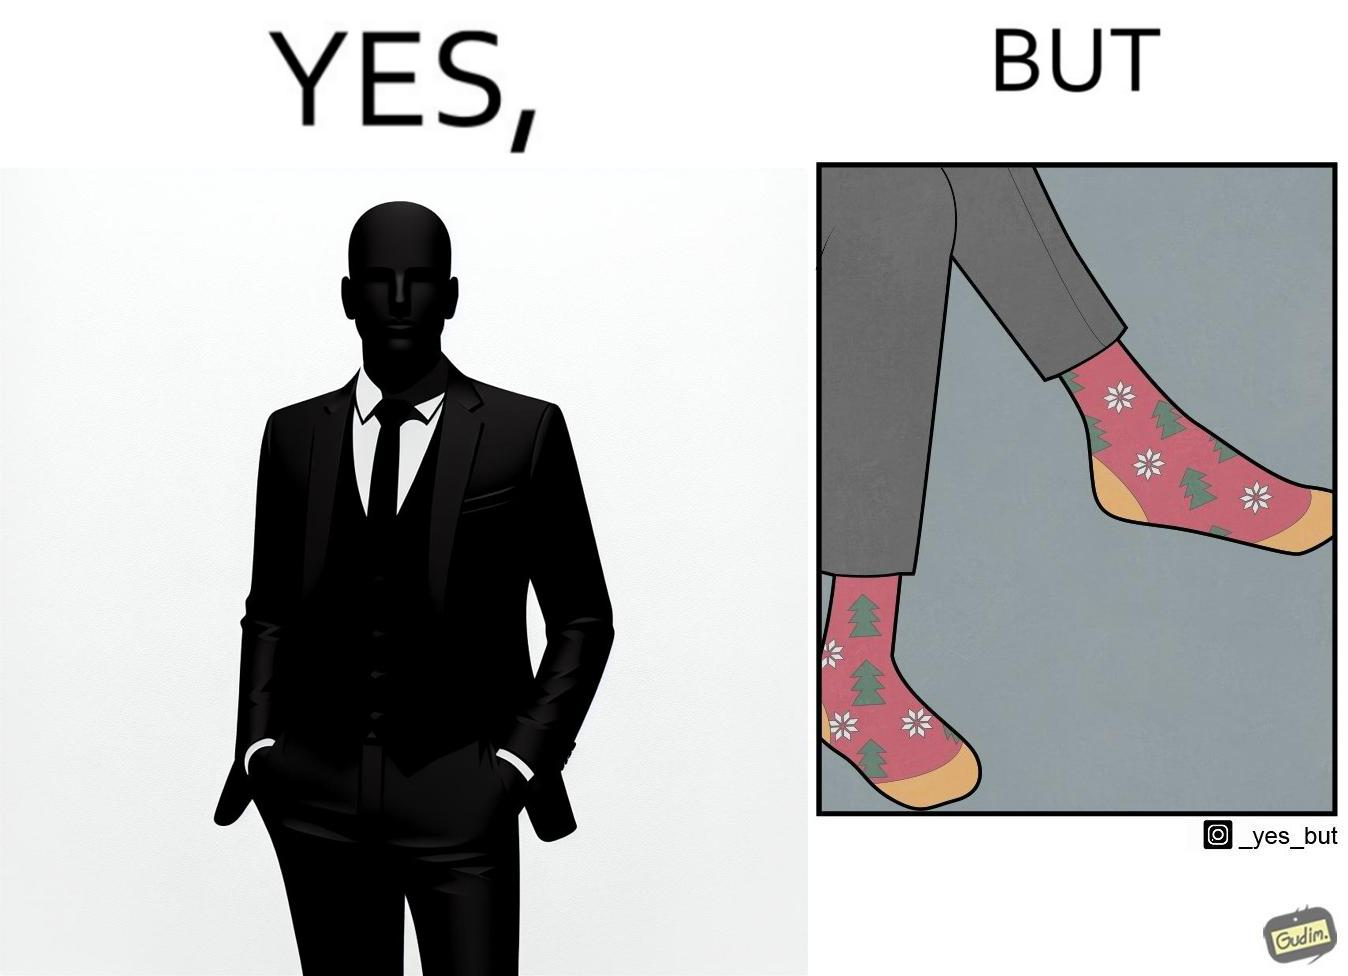Describe the contrast between the left and right parts of this image. In the left part of the image: A person in black formal suit and pants In the right part of the image: Legs of a person with black pants, and colorful socks with flowers and trees drawn on it. 